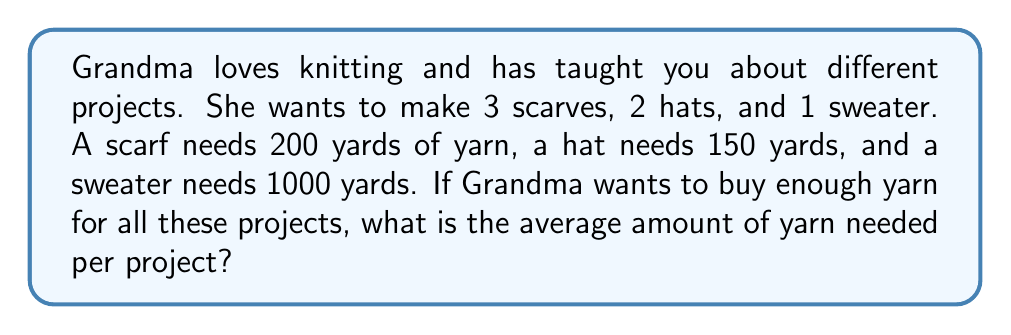What is the answer to this math problem? Let's approach this step-by-step:

1. First, we need to calculate the total amount of yarn needed for all projects:
   
   Scarves: $3 \times 200 = 600$ yards
   Hats: $2 \times 150 = 300$ yards
   Sweater: $1 \times 1000 = 1000$ yards

   Total yarn: $600 + 300 + 1000 = 1900$ yards

2. Next, we need to count the total number of projects:
   
   $3$ scarves + $2$ hats + $1$ sweater = $6$ projects in total

3. To find the average, we divide the total amount of yarn by the number of projects:

   $$ \text{Average} = \frac{\text{Total yarn}}{\text{Number of projects}} = \frac{1900}{6} $$

4. Performing the division:

   $$ \frac{1900}{6} = 316.6666... $$

5. Rounding to the nearest whole number (since we can't use a fraction of a yard):

   $316.6666...$ rounds to $317$ yards

Therefore, the average amount of yarn needed per project is 317 yards.
Answer: 317 yards 